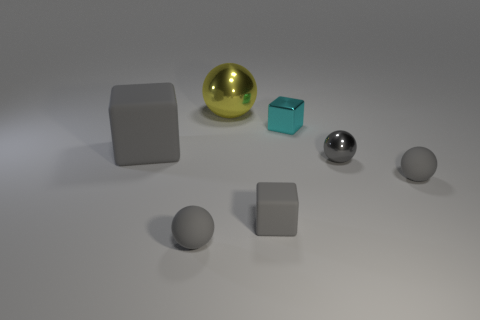Subtract all big yellow balls. How many balls are left? 3 Add 3 yellow spheres. How many objects exist? 10 Subtract 1 spheres. How many spheres are left? 3 Subtract all gray spheres. How many spheres are left? 1 Subtract all blocks. How many objects are left? 4 Subtract 0 brown cylinders. How many objects are left? 7 Subtract all green blocks. Subtract all brown balls. How many blocks are left? 3 Subtract all blue blocks. How many cyan spheres are left? 0 Subtract all tiny green metal balls. Subtract all small cyan metallic cubes. How many objects are left? 6 Add 2 small things. How many small things are left? 7 